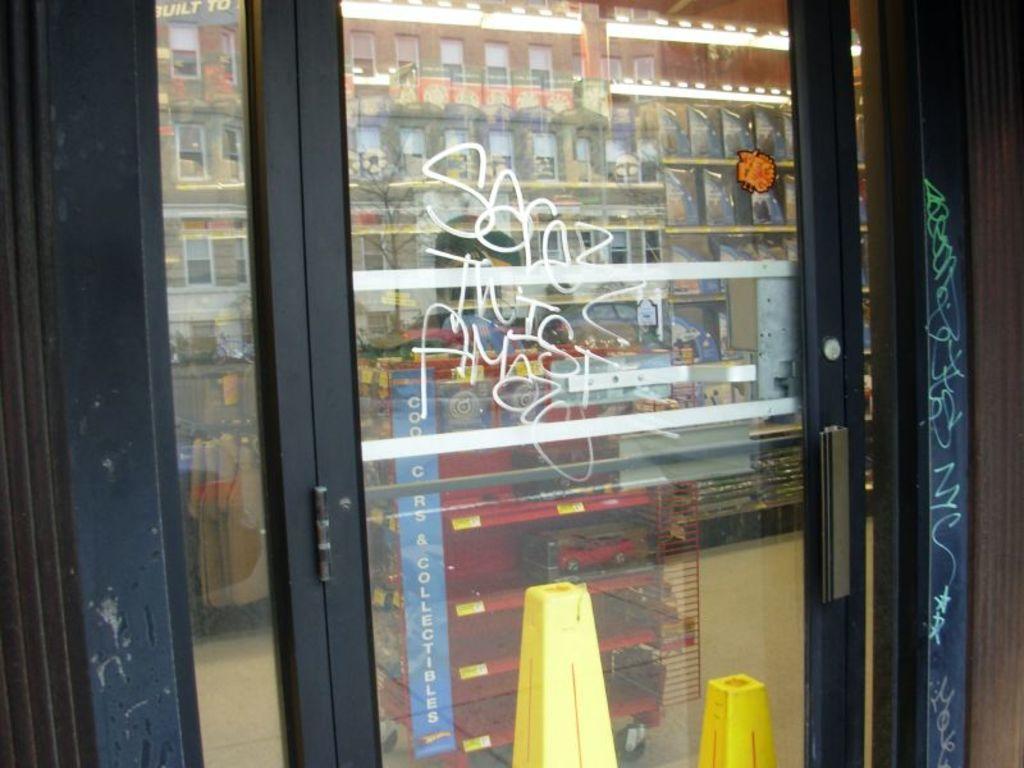Could you give a brief overview of what you see in this image? In this image we can see a glass door with some text on it, through the glass door, we can see some buildings and other objects. 